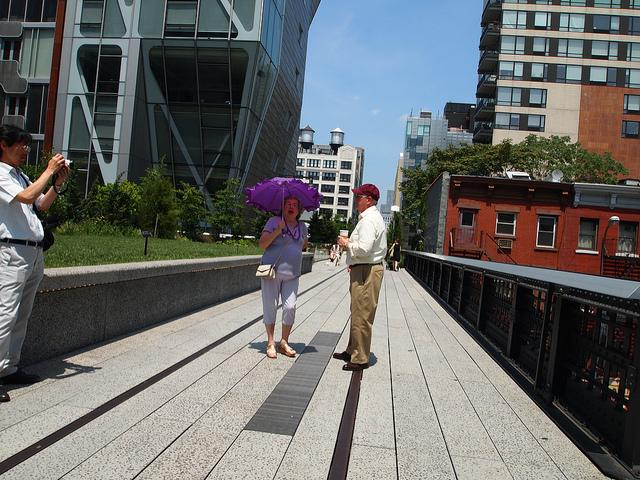The tanks seen in the background above the building once held what? water 